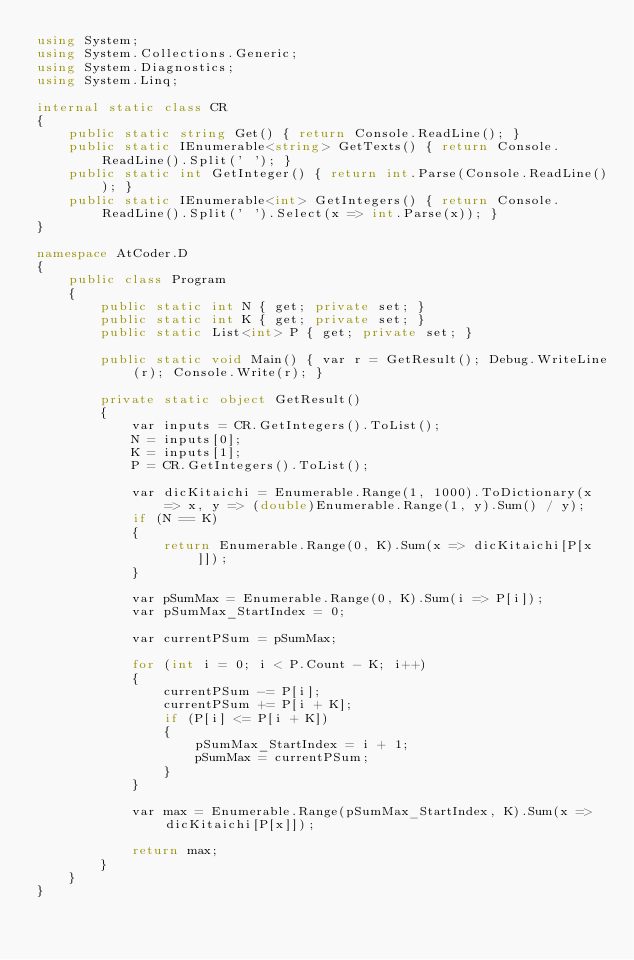<code> <loc_0><loc_0><loc_500><loc_500><_C#_>using System;
using System.Collections.Generic;
using System.Diagnostics;
using System.Linq;

internal static class CR
{
    public static string Get() { return Console.ReadLine(); }
    public static IEnumerable<string> GetTexts() { return Console.ReadLine().Split(' '); }
    public static int GetInteger() { return int.Parse(Console.ReadLine()); }
    public static IEnumerable<int> GetIntegers() { return Console.ReadLine().Split(' ').Select(x => int.Parse(x)); }
}

namespace AtCoder.D
{
    public class Program
    {
        public static int N { get; private set; }
        public static int K { get; private set; }
        public static List<int> P { get; private set; }

        public static void Main() { var r = GetResult(); Debug.WriteLine(r); Console.Write(r); }

        private static object GetResult()
        {
            var inputs = CR.GetIntegers().ToList();
            N = inputs[0];
            K = inputs[1];
            P = CR.GetIntegers().ToList();

            var dicKitaichi = Enumerable.Range(1, 1000).ToDictionary(x => x, y => (double)Enumerable.Range(1, y).Sum() / y);
            if (N == K)
            {
                return Enumerable.Range(0, K).Sum(x => dicKitaichi[P[x]]);
            }

            var pSumMax = Enumerable.Range(0, K).Sum(i => P[i]);
            var pSumMax_StartIndex = 0;

            var currentPSum = pSumMax;

            for (int i = 0; i < P.Count - K; i++)
            {
                currentPSum -= P[i];
                currentPSum += P[i + K];
                if (P[i] <= P[i + K])
                {
                    pSumMax_StartIndex = i + 1;
                    pSumMax = currentPSum;
                }
            }

            var max = Enumerable.Range(pSumMax_StartIndex, K).Sum(x => dicKitaichi[P[x]]);

            return max;
        }
    }
}
</code> 